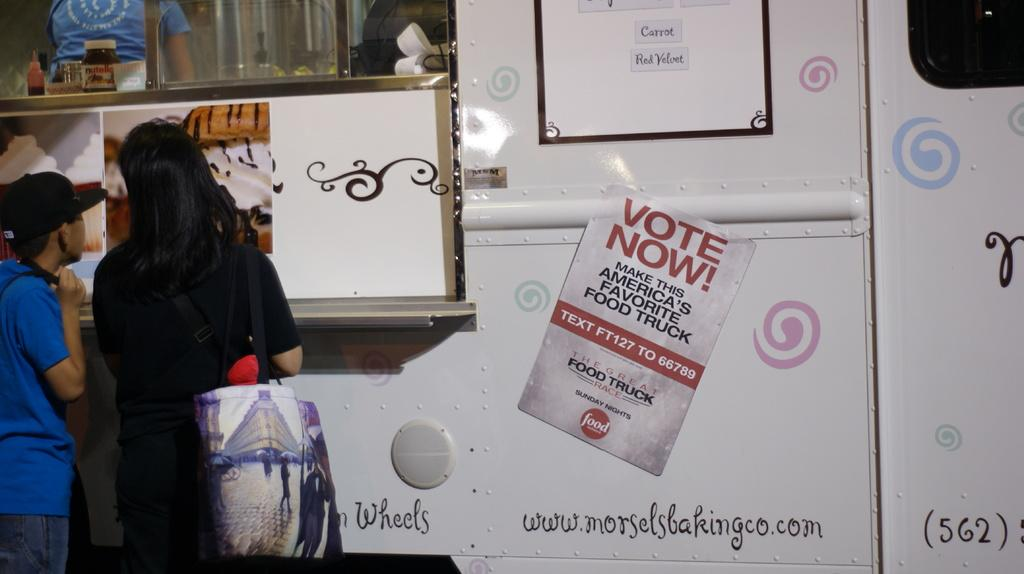How many people are in the image? There are two persons in the image. What can be seen in the background of the image? There is a vehicle, posters, glass, and bottles in the background of the image. What object is present in the image that might be used for carrying items? There is a bag in the image. Can you describe the scene involving the vehicle in the background? There is a person inside a vehicle in the image. What type of arithmetic problem can be solved using the bottles in the image? There is no arithmetic problem present in the image, as it features a scene with two people, a vehicle, posters, glass, bottles, and a bag. 